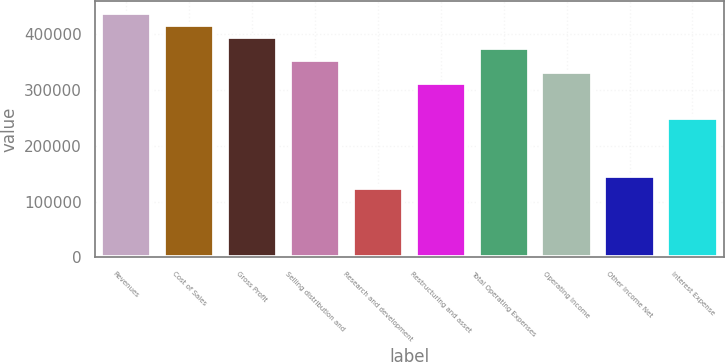Convert chart to OTSL. <chart><loc_0><loc_0><loc_500><loc_500><bar_chart><fcel>Revenues<fcel>Cost of Sales<fcel>Gross Profit<fcel>Selling distribution and<fcel>Research and development<fcel>Restructuring and asset<fcel>Total Operating Expenses<fcel>Operating Income<fcel>Other Income Net<fcel>Interest Expense<nl><fcel>437550<fcel>416714<fcel>395878<fcel>354207<fcel>125014<fcel>312536<fcel>375043<fcel>333371<fcel>145850<fcel>250028<nl></chart> 